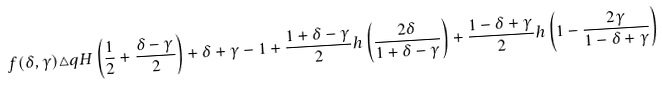Convert formula to latex. <formula><loc_0><loc_0><loc_500><loc_500>f ( \delta , \gamma ) \triangle q H \left ( \frac { 1 } { 2 } + \frac { \delta - \gamma } { 2 } \right ) + \delta + \gamma - 1 + \frac { 1 + \delta - \gamma } { 2 } h \left ( \frac { 2 \delta } { 1 + \delta - \gamma } \right ) + \frac { 1 - \delta + \gamma } { 2 } h \left ( 1 - \frac { 2 \gamma } { 1 - \delta + \gamma } \right )</formula> 